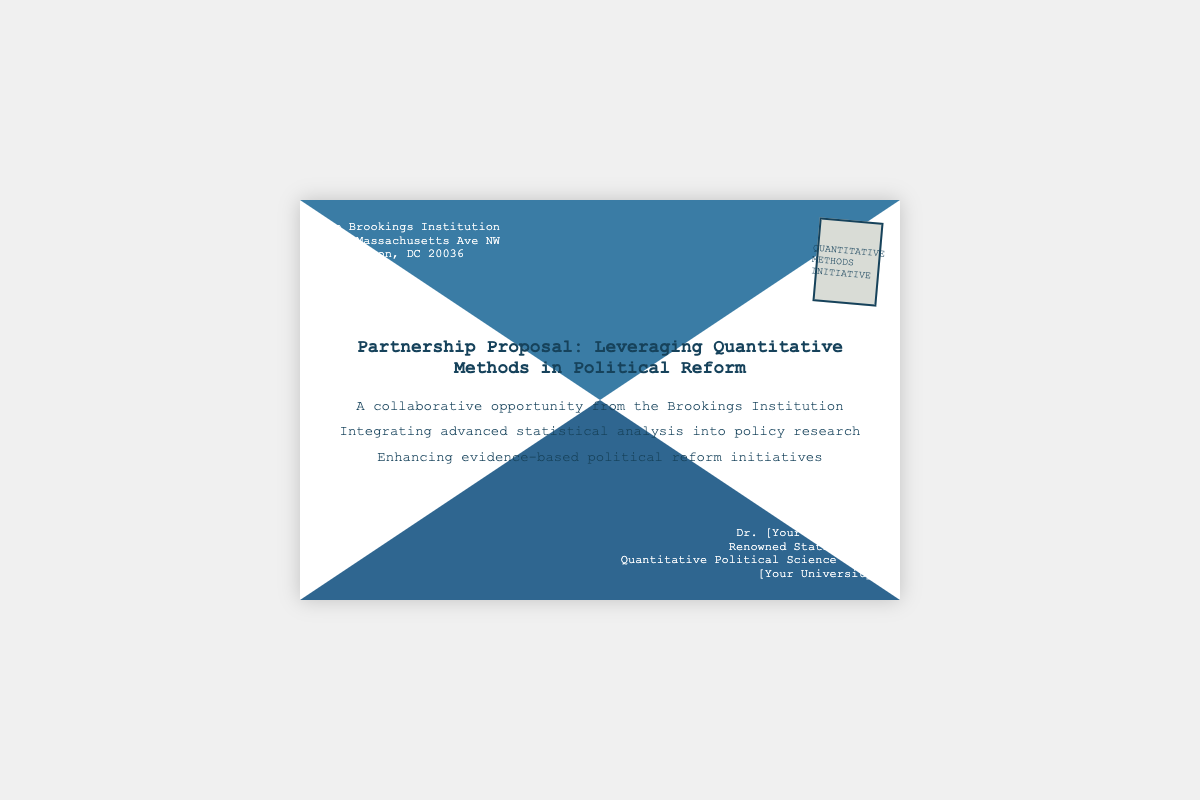what is the sender's organization? The sender's organization is mentioned in the top left corner of the envelope.
Answer: The Brookings Institution what is the recipient's profession? The recipient's profession is described in the bottom right corner of the envelope.
Answer: Renowned Statistician which city is the sender located in? The city of the sender's address is listed in the document.
Answer: Washington what is the primary focus of the partnership proposal? The focus is outlined in the title of the document, indicating what the collaboration entails.
Answer: Leveraging Quantitative Methods in Political Reform what does the stamp signify? The stamp contains text that indicates the initiative associated with the envelope.
Answer: Quantitative Methods Initiative what is the primary benefit mentioned in the proposal? The primary benefit is noted in the content area discussing the goals of the collaboration.
Answer: Enhancing evidence-based political reform initiatives how many addresses are listed in the envelope? The number of distinct addresses on the envelope is accounted for by examining the sender and recipient sections.
Answer: Two what is the document type being discussed? The type of document is indicated in the title of the proposal.
Answer: Partnership Proposal who is the proposal directed to? The proposal specifies the intended recipient in the bottom right corner.
Answer: Dr. [Your Last Name] 